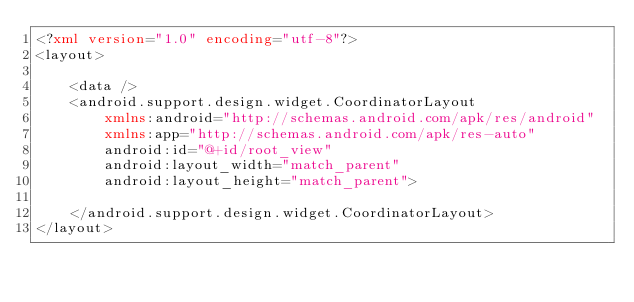<code> <loc_0><loc_0><loc_500><loc_500><_XML_><?xml version="1.0" encoding="utf-8"?>
<layout>

    <data />
    <android.support.design.widget.CoordinatorLayout
        xmlns:android="http://schemas.android.com/apk/res/android"
        xmlns:app="http://schemas.android.com/apk/res-auto"
        android:id="@+id/root_view"
        android:layout_width="match_parent"
        android:layout_height="match_parent">

    </android.support.design.widget.CoordinatorLayout>
</layout></code> 